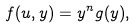Convert formula to latex. <formula><loc_0><loc_0><loc_500><loc_500>f ( u , y ) = y ^ { n } g ( y ) ,</formula> 